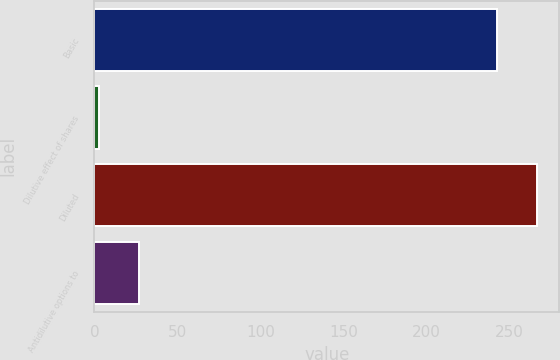Convert chart. <chart><loc_0><loc_0><loc_500><loc_500><bar_chart><fcel>Basic<fcel>Dilutive effect of shares<fcel>Diluted<fcel>Antidilutive options to<nl><fcel>242.4<fcel>2.9<fcel>266.64<fcel>27.14<nl></chart> 